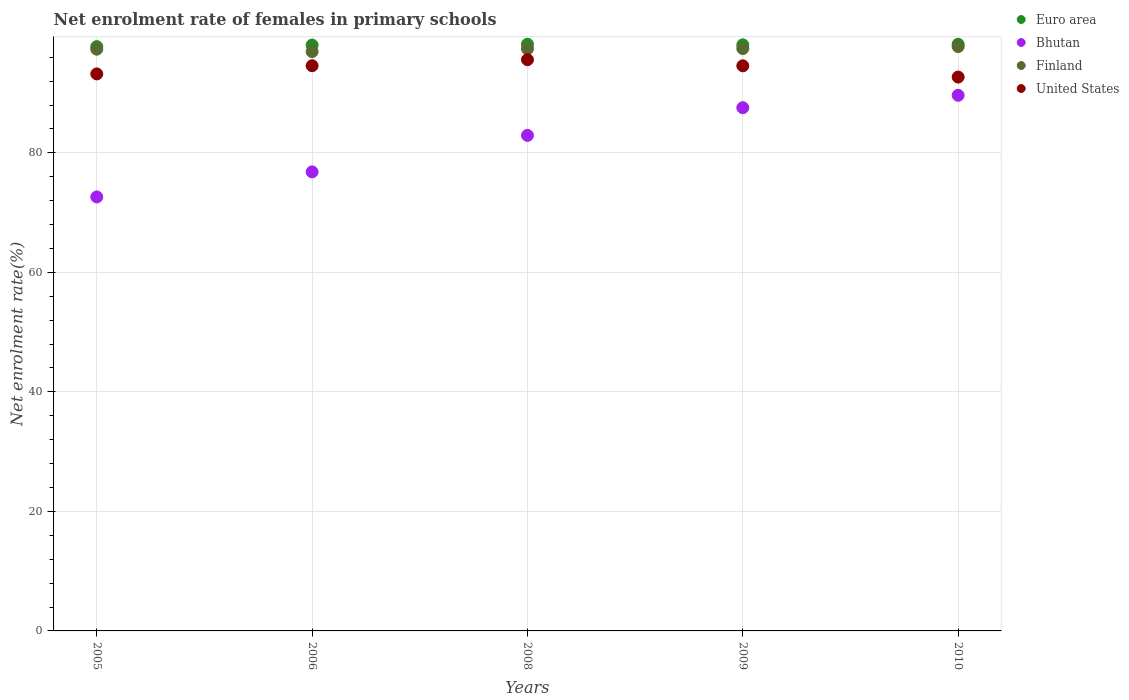How many different coloured dotlines are there?
Offer a terse response. 4. What is the net enrolment rate of females in primary schools in Finland in 2009?
Keep it short and to the point. 97.46. Across all years, what is the maximum net enrolment rate of females in primary schools in Euro area?
Provide a succinct answer. 98.19. Across all years, what is the minimum net enrolment rate of females in primary schools in Euro area?
Your answer should be very brief. 97.78. In which year was the net enrolment rate of females in primary schools in Finland maximum?
Provide a short and direct response. 2010. In which year was the net enrolment rate of females in primary schools in Euro area minimum?
Your answer should be very brief. 2005. What is the total net enrolment rate of females in primary schools in Euro area in the graph?
Your answer should be very brief. 490.27. What is the difference between the net enrolment rate of females in primary schools in Euro area in 2005 and that in 2008?
Your response must be concise. -0.4. What is the difference between the net enrolment rate of females in primary schools in United States in 2006 and the net enrolment rate of females in primary schools in Euro area in 2009?
Your response must be concise. -3.49. What is the average net enrolment rate of females in primary schools in United States per year?
Provide a short and direct response. 94.13. In the year 2005, what is the difference between the net enrolment rate of females in primary schools in United States and net enrolment rate of females in primary schools in Finland?
Ensure brevity in your answer.  -4.14. In how many years, is the net enrolment rate of females in primary schools in Bhutan greater than 32 %?
Offer a terse response. 5. What is the ratio of the net enrolment rate of females in primary schools in United States in 2005 to that in 2008?
Ensure brevity in your answer.  0.98. Is the net enrolment rate of females in primary schools in Bhutan in 2009 less than that in 2010?
Offer a terse response. Yes. What is the difference between the highest and the second highest net enrolment rate of females in primary schools in United States?
Your answer should be very brief. 1.01. What is the difference between the highest and the lowest net enrolment rate of females in primary schools in United States?
Provide a succinct answer. 2.9. Is it the case that in every year, the sum of the net enrolment rate of females in primary schools in Euro area and net enrolment rate of females in primary schools in Finland  is greater than the sum of net enrolment rate of females in primary schools in United States and net enrolment rate of females in primary schools in Bhutan?
Provide a succinct answer. No. Is it the case that in every year, the sum of the net enrolment rate of females in primary schools in Finland and net enrolment rate of females in primary schools in Bhutan  is greater than the net enrolment rate of females in primary schools in United States?
Offer a very short reply. Yes. Is the net enrolment rate of females in primary schools in Bhutan strictly greater than the net enrolment rate of females in primary schools in Finland over the years?
Provide a short and direct response. No. Is the net enrolment rate of females in primary schools in United States strictly less than the net enrolment rate of females in primary schools in Euro area over the years?
Your answer should be very brief. Yes. Does the graph contain any zero values?
Keep it short and to the point. No. Where does the legend appear in the graph?
Make the answer very short. Top right. What is the title of the graph?
Offer a very short reply. Net enrolment rate of females in primary schools. Does "Latvia" appear as one of the legend labels in the graph?
Offer a terse response. No. What is the label or title of the X-axis?
Give a very brief answer. Years. What is the label or title of the Y-axis?
Your answer should be very brief. Net enrolment rate(%). What is the Net enrolment rate(%) in Euro area in 2005?
Offer a very short reply. 97.78. What is the Net enrolment rate(%) in Bhutan in 2005?
Your response must be concise. 72.63. What is the Net enrolment rate(%) of Finland in 2005?
Make the answer very short. 97.35. What is the Net enrolment rate(%) of United States in 2005?
Offer a terse response. 93.22. What is the Net enrolment rate(%) of Euro area in 2006?
Give a very brief answer. 98.04. What is the Net enrolment rate(%) in Bhutan in 2006?
Offer a terse response. 76.82. What is the Net enrolment rate(%) in Finland in 2006?
Keep it short and to the point. 96.96. What is the Net enrolment rate(%) of United States in 2006?
Your answer should be very brief. 94.58. What is the Net enrolment rate(%) in Euro area in 2008?
Offer a terse response. 98.19. What is the Net enrolment rate(%) in Bhutan in 2008?
Provide a short and direct response. 82.93. What is the Net enrolment rate(%) in Finland in 2008?
Offer a terse response. 97.41. What is the Net enrolment rate(%) of United States in 2008?
Give a very brief answer. 95.59. What is the Net enrolment rate(%) of Euro area in 2009?
Offer a terse response. 98.08. What is the Net enrolment rate(%) in Bhutan in 2009?
Your answer should be compact. 87.56. What is the Net enrolment rate(%) in Finland in 2009?
Your response must be concise. 97.46. What is the Net enrolment rate(%) in United States in 2009?
Give a very brief answer. 94.57. What is the Net enrolment rate(%) in Euro area in 2010?
Ensure brevity in your answer.  98.18. What is the Net enrolment rate(%) of Bhutan in 2010?
Provide a succinct answer. 89.63. What is the Net enrolment rate(%) of Finland in 2010?
Offer a very short reply. 97.79. What is the Net enrolment rate(%) in United States in 2010?
Give a very brief answer. 92.69. Across all years, what is the maximum Net enrolment rate(%) of Euro area?
Your response must be concise. 98.19. Across all years, what is the maximum Net enrolment rate(%) in Bhutan?
Provide a succinct answer. 89.63. Across all years, what is the maximum Net enrolment rate(%) of Finland?
Offer a very short reply. 97.79. Across all years, what is the maximum Net enrolment rate(%) in United States?
Keep it short and to the point. 95.59. Across all years, what is the minimum Net enrolment rate(%) of Euro area?
Ensure brevity in your answer.  97.78. Across all years, what is the minimum Net enrolment rate(%) of Bhutan?
Offer a very short reply. 72.63. Across all years, what is the minimum Net enrolment rate(%) in Finland?
Your response must be concise. 96.96. Across all years, what is the minimum Net enrolment rate(%) of United States?
Your answer should be very brief. 92.69. What is the total Net enrolment rate(%) in Euro area in the graph?
Your answer should be very brief. 490.27. What is the total Net enrolment rate(%) in Bhutan in the graph?
Make the answer very short. 409.57. What is the total Net enrolment rate(%) of Finland in the graph?
Provide a short and direct response. 486.97. What is the total Net enrolment rate(%) in United States in the graph?
Give a very brief answer. 470.65. What is the difference between the Net enrolment rate(%) in Euro area in 2005 and that in 2006?
Your response must be concise. -0.26. What is the difference between the Net enrolment rate(%) of Bhutan in 2005 and that in 2006?
Ensure brevity in your answer.  -4.19. What is the difference between the Net enrolment rate(%) in Finland in 2005 and that in 2006?
Provide a short and direct response. 0.4. What is the difference between the Net enrolment rate(%) in United States in 2005 and that in 2006?
Your answer should be compact. -1.37. What is the difference between the Net enrolment rate(%) in Euro area in 2005 and that in 2008?
Keep it short and to the point. -0.4. What is the difference between the Net enrolment rate(%) in Bhutan in 2005 and that in 2008?
Your answer should be very brief. -10.3. What is the difference between the Net enrolment rate(%) in Finland in 2005 and that in 2008?
Offer a very short reply. -0.06. What is the difference between the Net enrolment rate(%) of United States in 2005 and that in 2008?
Your response must be concise. -2.38. What is the difference between the Net enrolment rate(%) of Euro area in 2005 and that in 2009?
Your answer should be very brief. -0.29. What is the difference between the Net enrolment rate(%) in Bhutan in 2005 and that in 2009?
Make the answer very short. -14.93. What is the difference between the Net enrolment rate(%) in Finland in 2005 and that in 2009?
Give a very brief answer. -0.11. What is the difference between the Net enrolment rate(%) in United States in 2005 and that in 2009?
Provide a short and direct response. -1.36. What is the difference between the Net enrolment rate(%) in Euro area in 2005 and that in 2010?
Offer a very short reply. -0.39. What is the difference between the Net enrolment rate(%) in Bhutan in 2005 and that in 2010?
Provide a succinct answer. -17. What is the difference between the Net enrolment rate(%) in Finland in 2005 and that in 2010?
Give a very brief answer. -0.44. What is the difference between the Net enrolment rate(%) in United States in 2005 and that in 2010?
Offer a terse response. 0.53. What is the difference between the Net enrolment rate(%) in Euro area in 2006 and that in 2008?
Keep it short and to the point. -0.14. What is the difference between the Net enrolment rate(%) in Bhutan in 2006 and that in 2008?
Give a very brief answer. -6.11. What is the difference between the Net enrolment rate(%) in Finland in 2006 and that in 2008?
Provide a succinct answer. -0.46. What is the difference between the Net enrolment rate(%) in United States in 2006 and that in 2008?
Your answer should be very brief. -1.01. What is the difference between the Net enrolment rate(%) in Euro area in 2006 and that in 2009?
Your answer should be compact. -0.03. What is the difference between the Net enrolment rate(%) of Bhutan in 2006 and that in 2009?
Provide a short and direct response. -10.74. What is the difference between the Net enrolment rate(%) of Finland in 2006 and that in 2009?
Your answer should be compact. -0.5. What is the difference between the Net enrolment rate(%) of United States in 2006 and that in 2009?
Provide a short and direct response. 0.01. What is the difference between the Net enrolment rate(%) in Euro area in 2006 and that in 2010?
Provide a succinct answer. -0.13. What is the difference between the Net enrolment rate(%) in Bhutan in 2006 and that in 2010?
Your answer should be very brief. -12.81. What is the difference between the Net enrolment rate(%) in Finland in 2006 and that in 2010?
Provide a succinct answer. -0.84. What is the difference between the Net enrolment rate(%) of United States in 2006 and that in 2010?
Your answer should be compact. 1.9. What is the difference between the Net enrolment rate(%) of Euro area in 2008 and that in 2009?
Your answer should be compact. 0.11. What is the difference between the Net enrolment rate(%) in Bhutan in 2008 and that in 2009?
Give a very brief answer. -4.63. What is the difference between the Net enrolment rate(%) in Finland in 2008 and that in 2009?
Keep it short and to the point. -0.05. What is the difference between the Net enrolment rate(%) in United States in 2008 and that in 2009?
Provide a short and direct response. 1.02. What is the difference between the Net enrolment rate(%) in Euro area in 2008 and that in 2010?
Offer a terse response. 0.01. What is the difference between the Net enrolment rate(%) in Bhutan in 2008 and that in 2010?
Your response must be concise. -6.71. What is the difference between the Net enrolment rate(%) in Finland in 2008 and that in 2010?
Give a very brief answer. -0.38. What is the difference between the Net enrolment rate(%) in United States in 2008 and that in 2010?
Provide a succinct answer. 2.9. What is the difference between the Net enrolment rate(%) of Euro area in 2009 and that in 2010?
Provide a short and direct response. -0.1. What is the difference between the Net enrolment rate(%) of Bhutan in 2009 and that in 2010?
Your answer should be compact. -2.07. What is the difference between the Net enrolment rate(%) in Finland in 2009 and that in 2010?
Your answer should be very brief. -0.33. What is the difference between the Net enrolment rate(%) in United States in 2009 and that in 2010?
Offer a very short reply. 1.88. What is the difference between the Net enrolment rate(%) of Euro area in 2005 and the Net enrolment rate(%) of Bhutan in 2006?
Provide a succinct answer. 20.96. What is the difference between the Net enrolment rate(%) of Euro area in 2005 and the Net enrolment rate(%) of Finland in 2006?
Your answer should be compact. 0.83. What is the difference between the Net enrolment rate(%) of Euro area in 2005 and the Net enrolment rate(%) of United States in 2006?
Your answer should be very brief. 3.2. What is the difference between the Net enrolment rate(%) in Bhutan in 2005 and the Net enrolment rate(%) in Finland in 2006?
Give a very brief answer. -24.33. What is the difference between the Net enrolment rate(%) in Bhutan in 2005 and the Net enrolment rate(%) in United States in 2006?
Make the answer very short. -21.95. What is the difference between the Net enrolment rate(%) in Finland in 2005 and the Net enrolment rate(%) in United States in 2006?
Give a very brief answer. 2.77. What is the difference between the Net enrolment rate(%) in Euro area in 2005 and the Net enrolment rate(%) in Bhutan in 2008?
Your response must be concise. 14.85. What is the difference between the Net enrolment rate(%) of Euro area in 2005 and the Net enrolment rate(%) of Finland in 2008?
Make the answer very short. 0.37. What is the difference between the Net enrolment rate(%) of Euro area in 2005 and the Net enrolment rate(%) of United States in 2008?
Offer a very short reply. 2.19. What is the difference between the Net enrolment rate(%) of Bhutan in 2005 and the Net enrolment rate(%) of Finland in 2008?
Your response must be concise. -24.78. What is the difference between the Net enrolment rate(%) of Bhutan in 2005 and the Net enrolment rate(%) of United States in 2008?
Provide a succinct answer. -22.96. What is the difference between the Net enrolment rate(%) of Finland in 2005 and the Net enrolment rate(%) of United States in 2008?
Your response must be concise. 1.76. What is the difference between the Net enrolment rate(%) in Euro area in 2005 and the Net enrolment rate(%) in Bhutan in 2009?
Make the answer very short. 10.22. What is the difference between the Net enrolment rate(%) of Euro area in 2005 and the Net enrolment rate(%) of Finland in 2009?
Provide a short and direct response. 0.32. What is the difference between the Net enrolment rate(%) of Euro area in 2005 and the Net enrolment rate(%) of United States in 2009?
Ensure brevity in your answer.  3.21. What is the difference between the Net enrolment rate(%) of Bhutan in 2005 and the Net enrolment rate(%) of Finland in 2009?
Give a very brief answer. -24.83. What is the difference between the Net enrolment rate(%) in Bhutan in 2005 and the Net enrolment rate(%) in United States in 2009?
Ensure brevity in your answer.  -21.94. What is the difference between the Net enrolment rate(%) in Finland in 2005 and the Net enrolment rate(%) in United States in 2009?
Ensure brevity in your answer.  2.78. What is the difference between the Net enrolment rate(%) of Euro area in 2005 and the Net enrolment rate(%) of Bhutan in 2010?
Your response must be concise. 8.15. What is the difference between the Net enrolment rate(%) of Euro area in 2005 and the Net enrolment rate(%) of Finland in 2010?
Your answer should be very brief. -0.01. What is the difference between the Net enrolment rate(%) of Euro area in 2005 and the Net enrolment rate(%) of United States in 2010?
Make the answer very short. 5.09. What is the difference between the Net enrolment rate(%) of Bhutan in 2005 and the Net enrolment rate(%) of Finland in 2010?
Your answer should be very brief. -25.16. What is the difference between the Net enrolment rate(%) of Bhutan in 2005 and the Net enrolment rate(%) of United States in 2010?
Your response must be concise. -20.06. What is the difference between the Net enrolment rate(%) in Finland in 2005 and the Net enrolment rate(%) in United States in 2010?
Make the answer very short. 4.67. What is the difference between the Net enrolment rate(%) in Euro area in 2006 and the Net enrolment rate(%) in Bhutan in 2008?
Offer a terse response. 15.11. What is the difference between the Net enrolment rate(%) of Euro area in 2006 and the Net enrolment rate(%) of Finland in 2008?
Offer a very short reply. 0.63. What is the difference between the Net enrolment rate(%) in Euro area in 2006 and the Net enrolment rate(%) in United States in 2008?
Your answer should be very brief. 2.45. What is the difference between the Net enrolment rate(%) of Bhutan in 2006 and the Net enrolment rate(%) of Finland in 2008?
Keep it short and to the point. -20.59. What is the difference between the Net enrolment rate(%) in Bhutan in 2006 and the Net enrolment rate(%) in United States in 2008?
Offer a very short reply. -18.77. What is the difference between the Net enrolment rate(%) of Finland in 2006 and the Net enrolment rate(%) of United States in 2008?
Ensure brevity in your answer.  1.36. What is the difference between the Net enrolment rate(%) of Euro area in 2006 and the Net enrolment rate(%) of Bhutan in 2009?
Your response must be concise. 10.48. What is the difference between the Net enrolment rate(%) in Euro area in 2006 and the Net enrolment rate(%) in Finland in 2009?
Give a very brief answer. 0.58. What is the difference between the Net enrolment rate(%) in Euro area in 2006 and the Net enrolment rate(%) in United States in 2009?
Your answer should be compact. 3.47. What is the difference between the Net enrolment rate(%) of Bhutan in 2006 and the Net enrolment rate(%) of Finland in 2009?
Your answer should be compact. -20.64. What is the difference between the Net enrolment rate(%) in Bhutan in 2006 and the Net enrolment rate(%) in United States in 2009?
Ensure brevity in your answer.  -17.75. What is the difference between the Net enrolment rate(%) of Finland in 2006 and the Net enrolment rate(%) of United States in 2009?
Give a very brief answer. 2.39. What is the difference between the Net enrolment rate(%) of Euro area in 2006 and the Net enrolment rate(%) of Bhutan in 2010?
Your answer should be compact. 8.41. What is the difference between the Net enrolment rate(%) in Euro area in 2006 and the Net enrolment rate(%) in Finland in 2010?
Offer a very short reply. 0.25. What is the difference between the Net enrolment rate(%) of Euro area in 2006 and the Net enrolment rate(%) of United States in 2010?
Your response must be concise. 5.35. What is the difference between the Net enrolment rate(%) of Bhutan in 2006 and the Net enrolment rate(%) of Finland in 2010?
Offer a very short reply. -20.97. What is the difference between the Net enrolment rate(%) in Bhutan in 2006 and the Net enrolment rate(%) in United States in 2010?
Make the answer very short. -15.87. What is the difference between the Net enrolment rate(%) of Finland in 2006 and the Net enrolment rate(%) of United States in 2010?
Offer a terse response. 4.27. What is the difference between the Net enrolment rate(%) of Euro area in 2008 and the Net enrolment rate(%) of Bhutan in 2009?
Keep it short and to the point. 10.62. What is the difference between the Net enrolment rate(%) of Euro area in 2008 and the Net enrolment rate(%) of Finland in 2009?
Provide a short and direct response. 0.73. What is the difference between the Net enrolment rate(%) of Euro area in 2008 and the Net enrolment rate(%) of United States in 2009?
Offer a very short reply. 3.62. What is the difference between the Net enrolment rate(%) of Bhutan in 2008 and the Net enrolment rate(%) of Finland in 2009?
Your response must be concise. -14.53. What is the difference between the Net enrolment rate(%) of Bhutan in 2008 and the Net enrolment rate(%) of United States in 2009?
Your answer should be compact. -11.64. What is the difference between the Net enrolment rate(%) in Finland in 2008 and the Net enrolment rate(%) in United States in 2009?
Provide a succinct answer. 2.84. What is the difference between the Net enrolment rate(%) of Euro area in 2008 and the Net enrolment rate(%) of Bhutan in 2010?
Your answer should be very brief. 8.55. What is the difference between the Net enrolment rate(%) of Euro area in 2008 and the Net enrolment rate(%) of Finland in 2010?
Keep it short and to the point. 0.39. What is the difference between the Net enrolment rate(%) of Euro area in 2008 and the Net enrolment rate(%) of United States in 2010?
Your answer should be compact. 5.5. What is the difference between the Net enrolment rate(%) of Bhutan in 2008 and the Net enrolment rate(%) of Finland in 2010?
Make the answer very short. -14.86. What is the difference between the Net enrolment rate(%) in Bhutan in 2008 and the Net enrolment rate(%) in United States in 2010?
Ensure brevity in your answer.  -9.76. What is the difference between the Net enrolment rate(%) of Finland in 2008 and the Net enrolment rate(%) of United States in 2010?
Ensure brevity in your answer.  4.72. What is the difference between the Net enrolment rate(%) in Euro area in 2009 and the Net enrolment rate(%) in Bhutan in 2010?
Give a very brief answer. 8.44. What is the difference between the Net enrolment rate(%) in Euro area in 2009 and the Net enrolment rate(%) in Finland in 2010?
Offer a very short reply. 0.28. What is the difference between the Net enrolment rate(%) of Euro area in 2009 and the Net enrolment rate(%) of United States in 2010?
Give a very brief answer. 5.39. What is the difference between the Net enrolment rate(%) of Bhutan in 2009 and the Net enrolment rate(%) of Finland in 2010?
Your answer should be compact. -10.23. What is the difference between the Net enrolment rate(%) of Bhutan in 2009 and the Net enrolment rate(%) of United States in 2010?
Offer a very short reply. -5.13. What is the difference between the Net enrolment rate(%) of Finland in 2009 and the Net enrolment rate(%) of United States in 2010?
Give a very brief answer. 4.77. What is the average Net enrolment rate(%) of Euro area per year?
Provide a short and direct response. 98.05. What is the average Net enrolment rate(%) in Bhutan per year?
Ensure brevity in your answer.  81.91. What is the average Net enrolment rate(%) of Finland per year?
Ensure brevity in your answer.  97.39. What is the average Net enrolment rate(%) of United States per year?
Offer a very short reply. 94.13. In the year 2005, what is the difference between the Net enrolment rate(%) of Euro area and Net enrolment rate(%) of Bhutan?
Provide a succinct answer. 25.15. In the year 2005, what is the difference between the Net enrolment rate(%) of Euro area and Net enrolment rate(%) of Finland?
Ensure brevity in your answer.  0.43. In the year 2005, what is the difference between the Net enrolment rate(%) of Euro area and Net enrolment rate(%) of United States?
Your response must be concise. 4.57. In the year 2005, what is the difference between the Net enrolment rate(%) in Bhutan and Net enrolment rate(%) in Finland?
Provide a succinct answer. -24.72. In the year 2005, what is the difference between the Net enrolment rate(%) in Bhutan and Net enrolment rate(%) in United States?
Give a very brief answer. -20.59. In the year 2005, what is the difference between the Net enrolment rate(%) in Finland and Net enrolment rate(%) in United States?
Give a very brief answer. 4.14. In the year 2006, what is the difference between the Net enrolment rate(%) in Euro area and Net enrolment rate(%) in Bhutan?
Ensure brevity in your answer.  21.22. In the year 2006, what is the difference between the Net enrolment rate(%) of Euro area and Net enrolment rate(%) of Finland?
Provide a succinct answer. 1.09. In the year 2006, what is the difference between the Net enrolment rate(%) of Euro area and Net enrolment rate(%) of United States?
Provide a succinct answer. 3.46. In the year 2006, what is the difference between the Net enrolment rate(%) of Bhutan and Net enrolment rate(%) of Finland?
Your answer should be compact. -20.14. In the year 2006, what is the difference between the Net enrolment rate(%) in Bhutan and Net enrolment rate(%) in United States?
Keep it short and to the point. -17.76. In the year 2006, what is the difference between the Net enrolment rate(%) of Finland and Net enrolment rate(%) of United States?
Keep it short and to the point. 2.37. In the year 2008, what is the difference between the Net enrolment rate(%) in Euro area and Net enrolment rate(%) in Bhutan?
Offer a very short reply. 15.26. In the year 2008, what is the difference between the Net enrolment rate(%) of Euro area and Net enrolment rate(%) of Finland?
Provide a short and direct response. 0.77. In the year 2008, what is the difference between the Net enrolment rate(%) in Euro area and Net enrolment rate(%) in United States?
Provide a succinct answer. 2.59. In the year 2008, what is the difference between the Net enrolment rate(%) in Bhutan and Net enrolment rate(%) in Finland?
Make the answer very short. -14.48. In the year 2008, what is the difference between the Net enrolment rate(%) of Bhutan and Net enrolment rate(%) of United States?
Your answer should be compact. -12.66. In the year 2008, what is the difference between the Net enrolment rate(%) in Finland and Net enrolment rate(%) in United States?
Give a very brief answer. 1.82. In the year 2009, what is the difference between the Net enrolment rate(%) of Euro area and Net enrolment rate(%) of Bhutan?
Give a very brief answer. 10.51. In the year 2009, what is the difference between the Net enrolment rate(%) of Euro area and Net enrolment rate(%) of Finland?
Offer a very short reply. 0.62. In the year 2009, what is the difference between the Net enrolment rate(%) of Euro area and Net enrolment rate(%) of United States?
Offer a very short reply. 3.51. In the year 2009, what is the difference between the Net enrolment rate(%) in Bhutan and Net enrolment rate(%) in Finland?
Offer a very short reply. -9.9. In the year 2009, what is the difference between the Net enrolment rate(%) in Bhutan and Net enrolment rate(%) in United States?
Offer a very short reply. -7.01. In the year 2009, what is the difference between the Net enrolment rate(%) of Finland and Net enrolment rate(%) of United States?
Offer a terse response. 2.89. In the year 2010, what is the difference between the Net enrolment rate(%) of Euro area and Net enrolment rate(%) of Bhutan?
Make the answer very short. 8.54. In the year 2010, what is the difference between the Net enrolment rate(%) in Euro area and Net enrolment rate(%) in Finland?
Make the answer very short. 0.39. In the year 2010, what is the difference between the Net enrolment rate(%) in Euro area and Net enrolment rate(%) in United States?
Offer a terse response. 5.49. In the year 2010, what is the difference between the Net enrolment rate(%) in Bhutan and Net enrolment rate(%) in Finland?
Provide a succinct answer. -8.16. In the year 2010, what is the difference between the Net enrolment rate(%) in Bhutan and Net enrolment rate(%) in United States?
Ensure brevity in your answer.  -3.05. In the year 2010, what is the difference between the Net enrolment rate(%) in Finland and Net enrolment rate(%) in United States?
Make the answer very short. 5.1. What is the ratio of the Net enrolment rate(%) in Euro area in 2005 to that in 2006?
Offer a terse response. 1. What is the ratio of the Net enrolment rate(%) of Bhutan in 2005 to that in 2006?
Offer a very short reply. 0.95. What is the ratio of the Net enrolment rate(%) in United States in 2005 to that in 2006?
Keep it short and to the point. 0.99. What is the ratio of the Net enrolment rate(%) in Euro area in 2005 to that in 2008?
Your answer should be very brief. 1. What is the ratio of the Net enrolment rate(%) in Bhutan in 2005 to that in 2008?
Make the answer very short. 0.88. What is the ratio of the Net enrolment rate(%) in United States in 2005 to that in 2008?
Offer a terse response. 0.98. What is the ratio of the Net enrolment rate(%) of Euro area in 2005 to that in 2009?
Ensure brevity in your answer.  1. What is the ratio of the Net enrolment rate(%) in Bhutan in 2005 to that in 2009?
Offer a very short reply. 0.83. What is the ratio of the Net enrolment rate(%) of United States in 2005 to that in 2009?
Your answer should be compact. 0.99. What is the ratio of the Net enrolment rate(%) of Bhutan in 2005 to that in 2010?
Ensure brevity in your answer.  0.81. What is the ratio of the Net enrolment rate(%) of United States in 2005 to that in 2010?
Ensure brevity in your answer.  1.01. What is the ratio of the Net enrolment rate(%) of Bhutan in 2006 to that in 2008?
Your response must be concise. 0.93. What is the ratio of the Net enrolment rate(%) of Bhutan in 2006 to that in 2009?
Give a very brief answer. 0.88. What is the ratio of the Net enrolment rate(%) of Finland in 2006 to that in 2009?
Provide a succinct answer. 0.99. What is the ratio of the Net enrolment rate(%) of Bhutan in 2006 to that in 2010?
Keep it short and to the point. 0.86. What is the ratio of the Net enrolment rate(%) in United States in 2006 to that in 2010?
Provide a short and direct response. 1.02. What is the ratio of the Net enrolment rate(%) of Euro area in 2008 to that in 2009?
Give a very brief answer. 1. What is the ratio of the Net enrolment rate(%) of Bhutan in 2008 to that in 2009?
Offer a very short reply. 0.95. What is the ratio of the Net enrolment rate(%) in Finland in 2008 to that in 2009?
Make the answer very short. 1. What is the ratio of the Net enrolment rate(%) of United States in 2008 to that in 2009?
Your answer should be compact. 1.01. What is the ratio of the Net enrolment rate(%) in Euro area in 2008 to that in 2010?
Make the answer very short. 1. What is the ratio of the Net enrolment rate(%) in Bhutan in 2008 to that in 2010?
Offer a terse response. 0.93. What is the ratio of the Net enrolment rate(%) in United States in 2008 to that in 2010?
Keep it short and to the point. 1.03. What is the ratio of the Net enrolment rate(%) in Bhutan in 2009 to that in 2010?
Your answer should be very brief. 0.98. What is the ratio of the Net enrolment rate(%) of United States in 2009 to that in 2010?
Provide a succinct answer. 1.02. What is the difference between the highest and the second highest Net enrolment rate(%) of Euro area?
Offer a terse response. 0.01. What is the difference between the highest and the second highest Net enrolment rate(%) of Bhutan?
Give a very brief answer. 2.07. What is the difference between the highest and the second highest Net enrolment rate(%) in Finland?
Offer a very short reply. 0.33. What is the difference between the highest and the second highest Net enrolment rate(%) in United States?
Ensure brevity in your answer.  1.01. What is the difference between the highest and the lowest Net enrolment rate(%) in Euro area?
Provide a succinct answer. 0.4. What is the difference between the highest and the lowest Net enrolment rate(%) in Bhutan?
Provide a succinct answer. 17. What is the difference between the highest and the lowest Net enrolment rate(%) in Finland?
Ensure brevity in your answer.  0.84. What is the difference between the highest and the lowest Net enrolment rate(%) in United States?
Your answer should be compact. 2.9. 